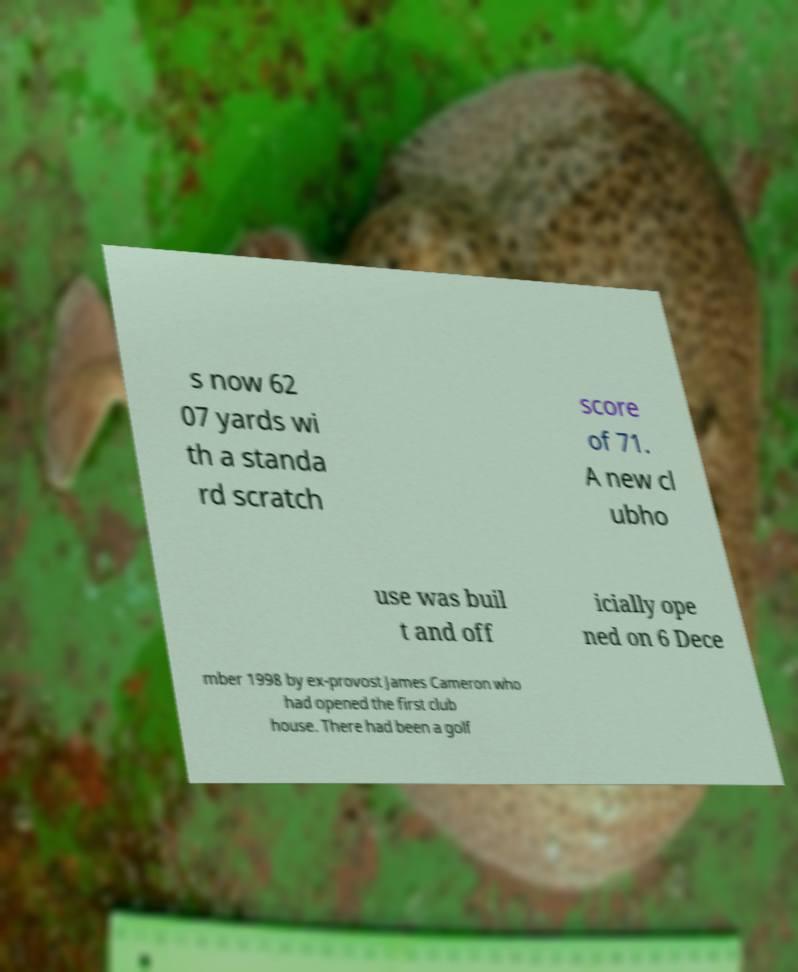Please read and relay the text visible in this image. What does it say? s now 62 07 yards wi th a standa rd scratch score of 71. A new cl ubho use was buil t and off icially ope ned on 6 Dece mber 1998 by ex-provost James Cameron who had opened the first club house. There had been a golf 